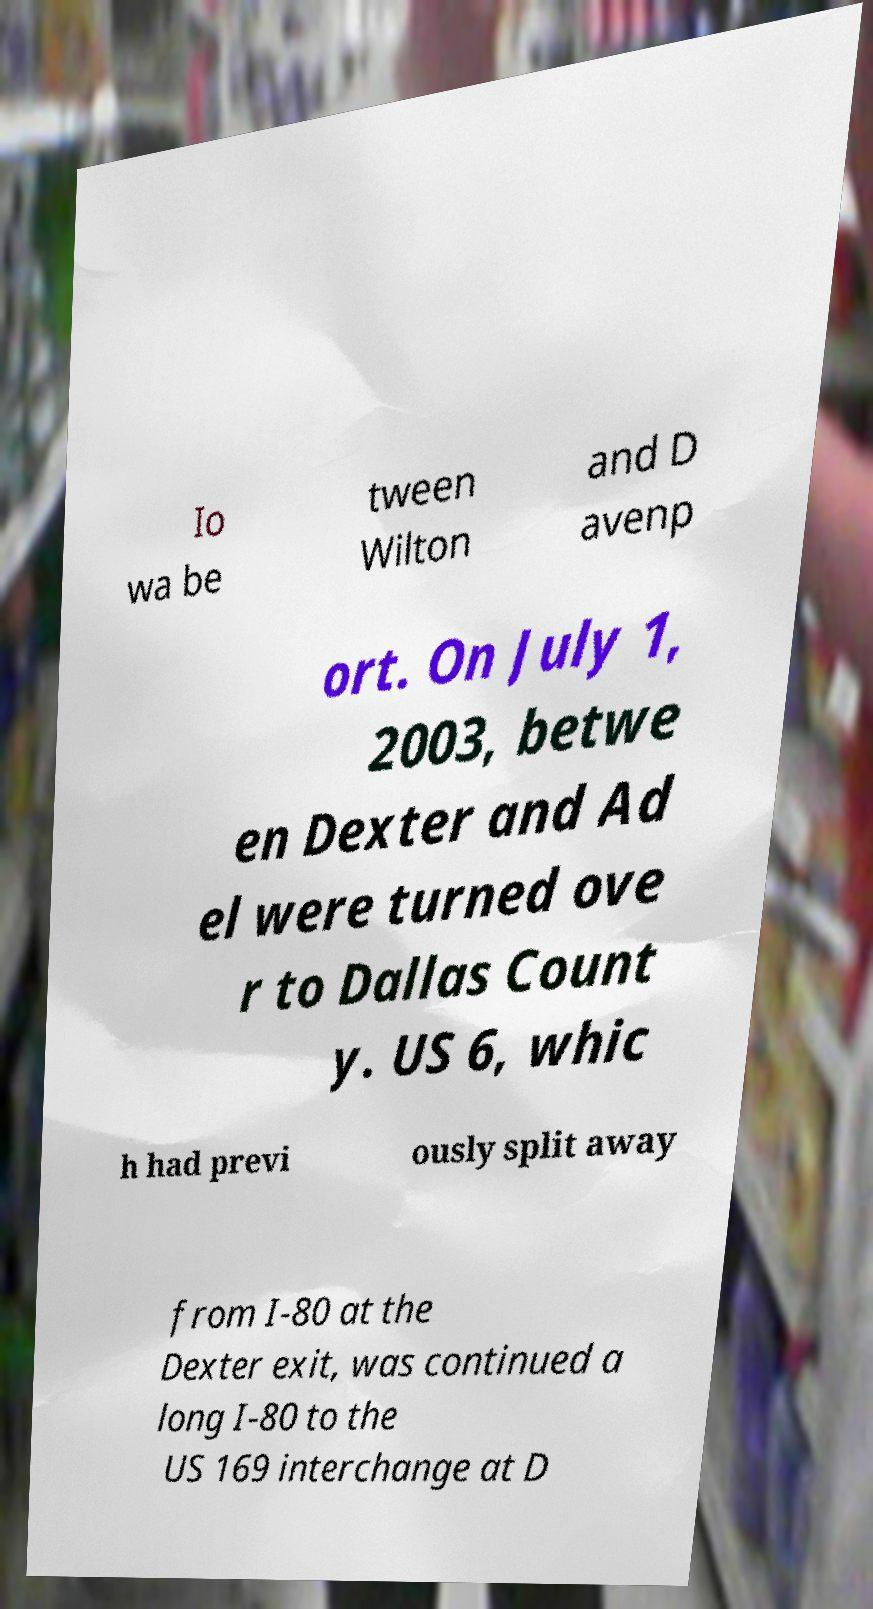What messages or text are displayed in this image? I need them in a readable, typed format. Io wa be tween Wilton and D avenp ort. On July 1, 2003, betwe en Dexter and Ad el were turned ove r to Dallas Count y. US 6, whic h had previ ously split away from I-80 at the Dexter exit, was continued a long I-80 to the US 169 interchange at D 